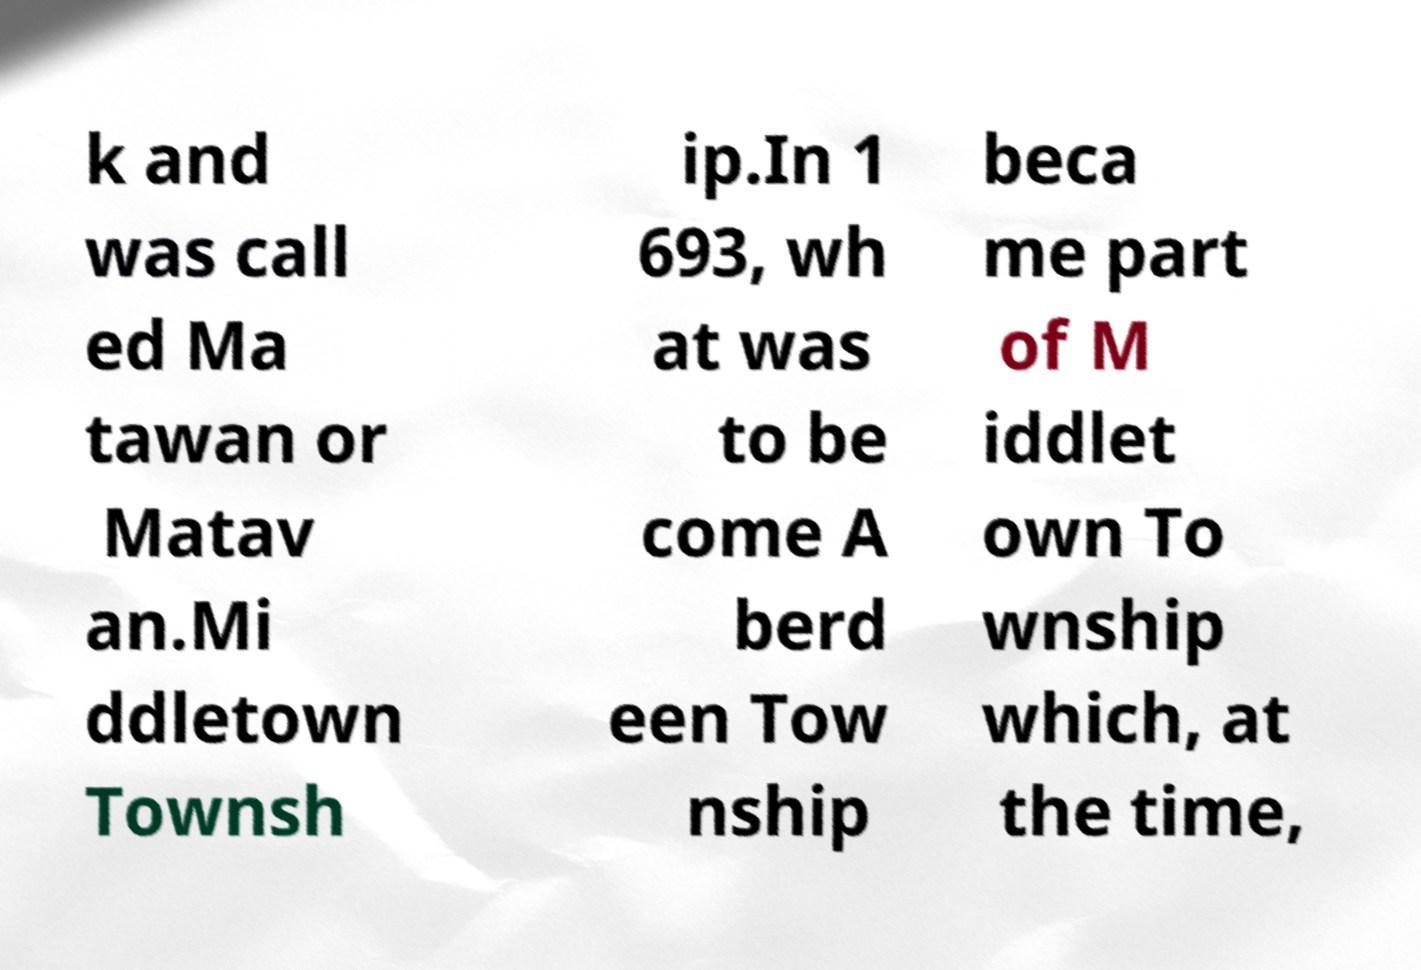Can you read and provide the text displayed in the image?This photo seems to have some interesting text. Can you extract and type it out for me? k and was call ed Ma tawan or Matav an.Mi ddletown Townsh ip.In 1 693, wh at was to be come A berd een Tow nship beca me part of M iddlet own To wnship which, at the time, 